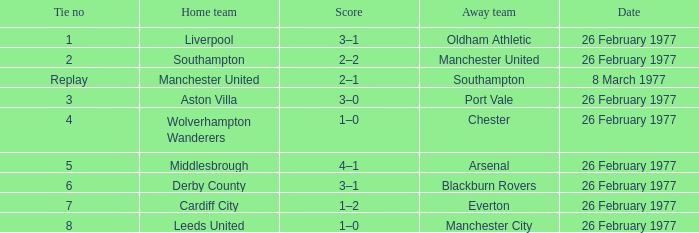What's the score when the Wolverhampton Wanderers played at home? 1–0. 